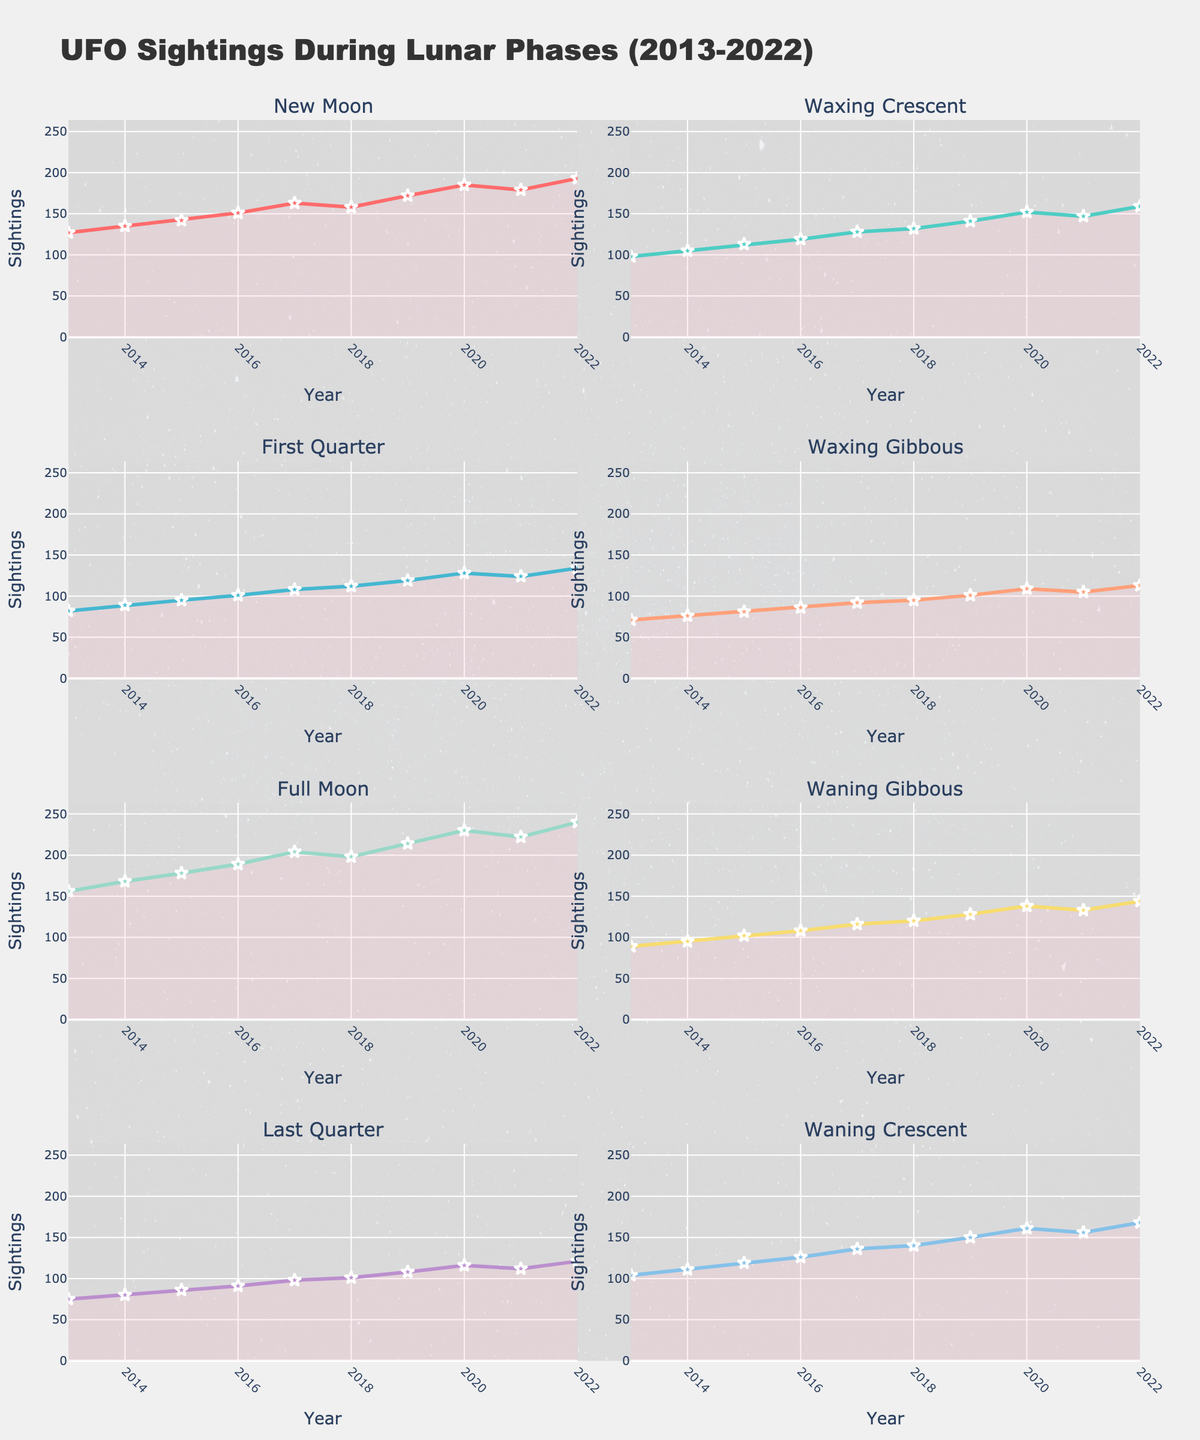How many games did the Los Angeles Dodgers win in June 2018? Look at the subplot for the Los Angeles Dodgers and find the bar for June 2018. The height of the bar represents the number of wins.
Answer: 17 Which team had the fewest wins in any month, and how many were there? Compare the heights of the bars across all subplots. The shortest bar will represent the fewest wins in a month.
Answer: San Francisco Giants, 8 (September 2019) What is the difference in the number of losses between July and August 2021 for the San Diego Padres? Identify the points for losses in July and August 2021 in the San Diego Padres subplot. Subtract the number of losses in July from the number in August.
Answer: 2 Which team had their best monthly performance in July, and what was it? Examine each subplot and find the month of July. Look for the highest bar in July across all teams and check the number of wins.
Answer: San Francisco Giants, 19 (July 2019) How many total games did the Colorado Rockies play in April 2022? For the Colorado Rockies subplot, add the number of Wins and Losses for April 2022.
Answer: 21 Which team showed the largest improvement from one month to the next in terms of wins? Compare the difference in wins month-to-month for each team. The largest increase will be the month with the greatest improvement.
Answer: Los Angeles Dodgers, from May to June 2018 (difference of 3) During which month and year did the San Francisco Giants experience their highest number of losses? Look at the losses plotted as line charts for the San Francisco Giants and identify the highest point.
Answer: September 2019 On average, how many games did the Arizona Diamondbacks win per month in the 2020 season? Add up the wins across all months for the Diamondbacks in 2020 and divide by the number of months. (5+8+12)/3 = 8.33
Answer: 8.33 What’s the combined total of wins for all teams in May across all seasons shown? Sum the number of wins in May for all teams by looking at each subplot.
Answer: 58 Which team had the most stable performance in terms of the least variation in wins month-to-month during their season? Compare the fluctuation in the heights of the bar charts across months for each team; the team with the most consistent bar heights had the most stable performance.
Answer: San Diego Padres, 2021 